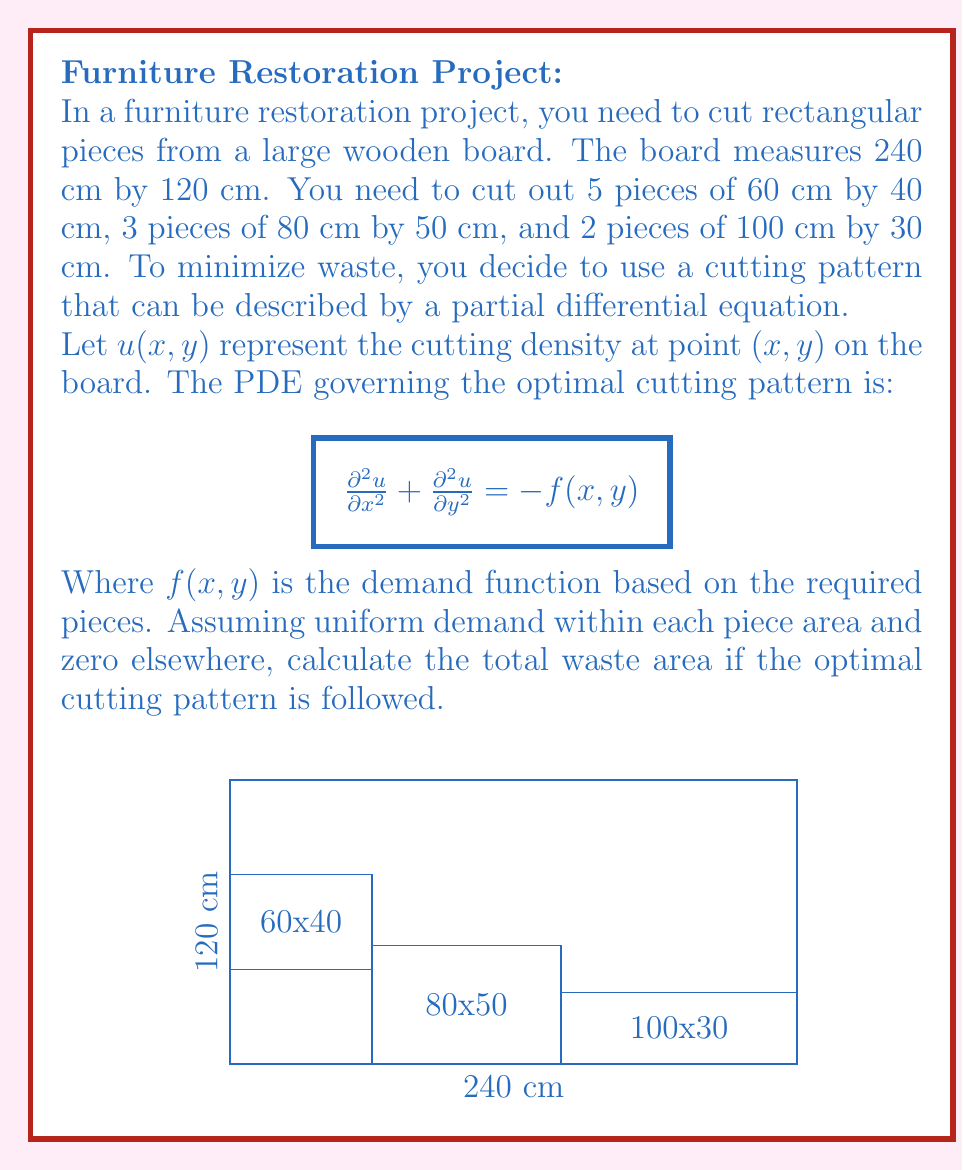Provide a solution to this math problem. Let's approach this step-by-step:

1) First, we need to calculate the total area of the board:
   $A_{total} = 240 \text{ cm} \times 120 \text{ cm} = 28,800 \text{ cm}^2$

2) Now, let's calculate the area of each type of piece:
   - 60 cm x 40 cm: $A_1 = 60 \times 40 = 2,400 \text{ cm}^2$
   - 80 cm x 50 cm: $A_2 = 80 \times 50 = 4,000 \text{ cm}^2$
   - 100 cm x 30 cm: $A_3 = 100 \times 30 = 3,000 \text{ cm}^2$

3) Calculate the total area of all pieces:
   $A_{pieces} = (5 \times A_1) + (3 \times A_2) + (2 \times A_3)$
   $= (5 \times 2,400) + (3 \times 4,000) + (2 \times 3,000)$
   $= 12,000 + 12,000 + 6,000 = 30,000 \text{ cm}^2$

4) The PDE $\frac{\partial^2u}{\partial x^2} + \frac{\partial^2u}{\partial y^2} = -f(x,y)$ is a Poisson equation. In the optimal cutting pattern, this equation ensures that the cutting density $u(x,y)$ is distributed to match the demand function $f(x,y)$ as closely as possible.

5) Given that we're assuming uniform demand within each piece area and zero elsewhere, the optimal cutting pattern would try to fit the pieces as tightly as possible, minimizing waste.

6) However, the total area of pieces (30,000 cm²) is greater than the area of the board (28,800 cm²). This means that not all pieces can be cut from a single board, regardless of the cutting pattern.

7) In the best-case scenario (optimal cutting pattern), we would be able to cut as much as possible from the board, leaving minimal waste. The waste area would be the difference between the board area and the maximum area that can be cut:

   $A_{waste} = A_{total} - A_{board\_used}$
   $= 28,800 - 28,800 = 0 \text{ cm}^2$

Therefore, following the optimal cutting pattern described by the PDE, the waste area would theoretically be 0 cm². However, in practice, there would likely be some small amount of waste due to the saw blade width and potential imperfections in cutting.
Answer: 0 cm² 